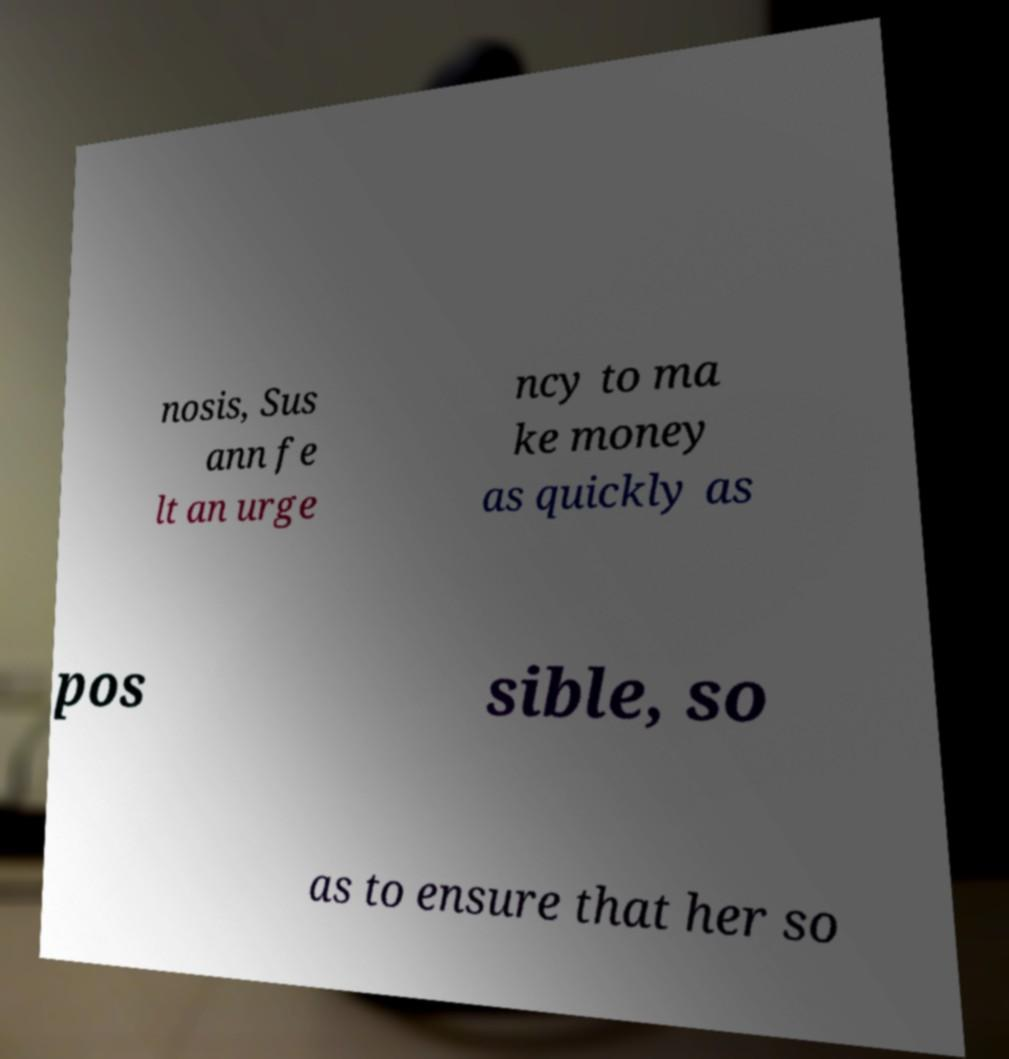Could you extract and type out the text from this image? nosis, Sus ann fe lt an urge ncy to ma ke money as quickly as pos sible, so as to ensure that her so 